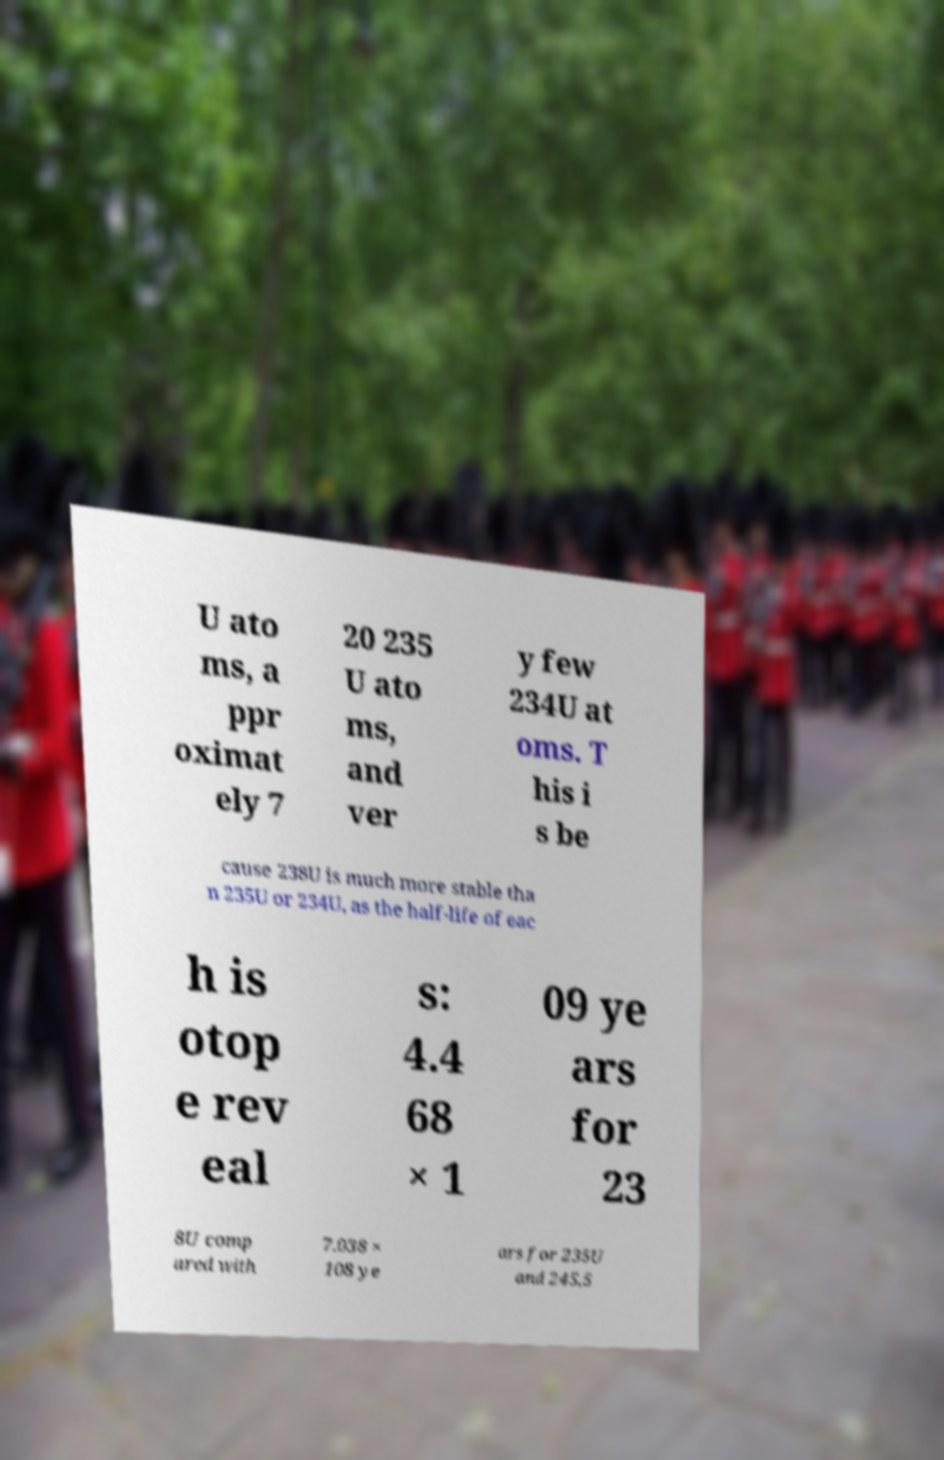Could you extract and type out the text from this image? U ato ms, a ppr oximat ely 7 20 235 U ato ms, and ver y few 234U at oms. T his i s be cause 238U is much more stable tha n 235U or 234U, as the half-life of eac h is otop e rev eal s: 4.4 68 × 1 09 ye ars for 23 8U comp ared with 7.038 × 108 ye ars for 235U and 245,5 